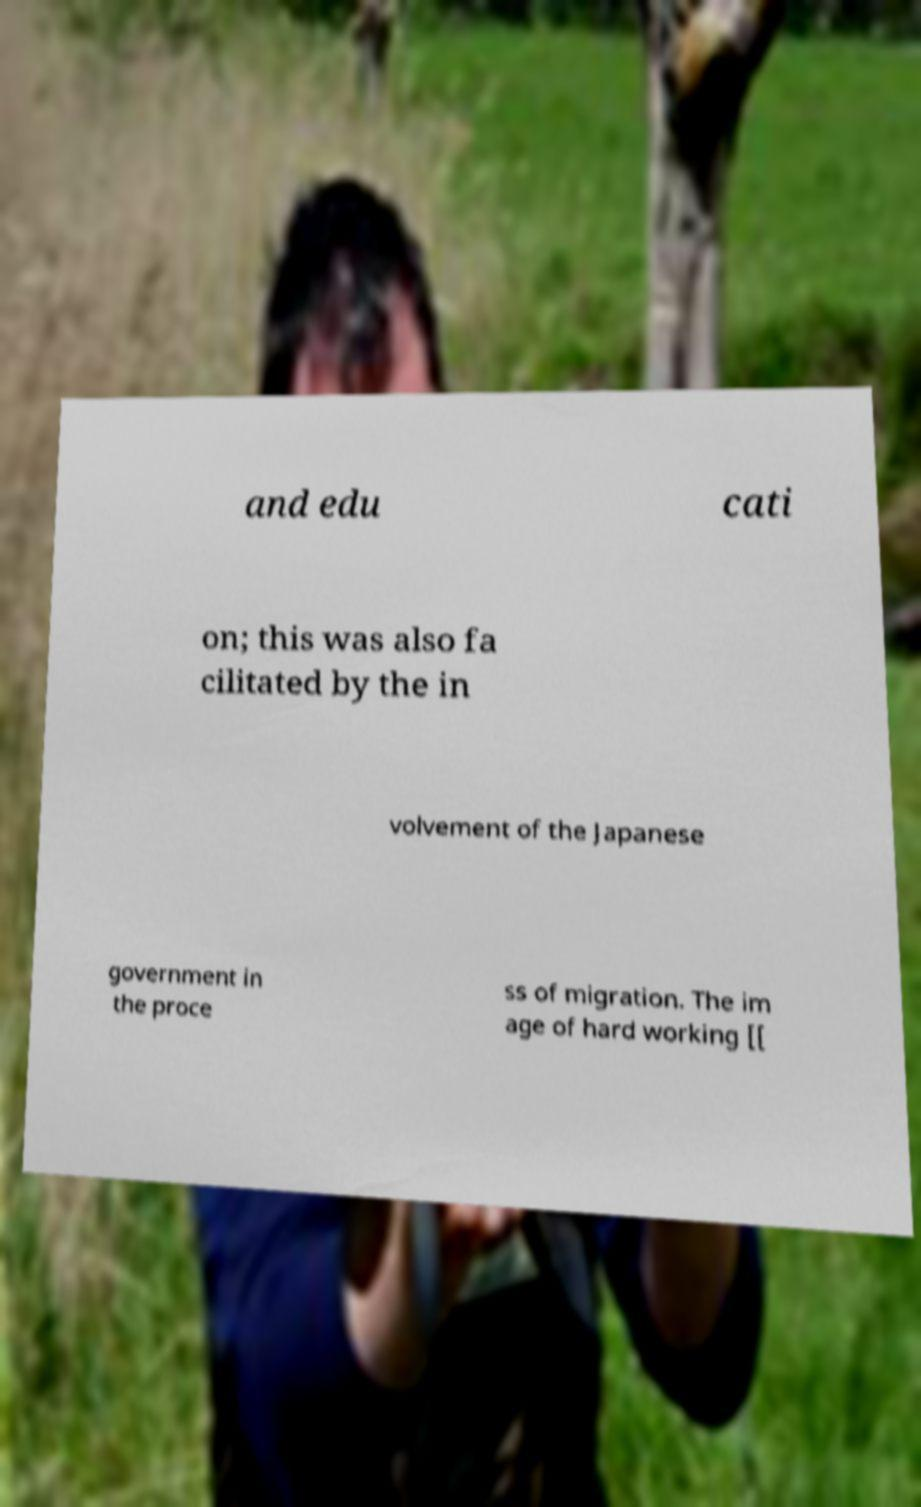Can you read and provide the text displayed in the image?This photo seems to have some interesting text. Can you extract and type it out for me? and edu cati on; this was also fa cilitated by the in volvement of the Japanese government in the proce ss of migration. The im age of hard working [[ 